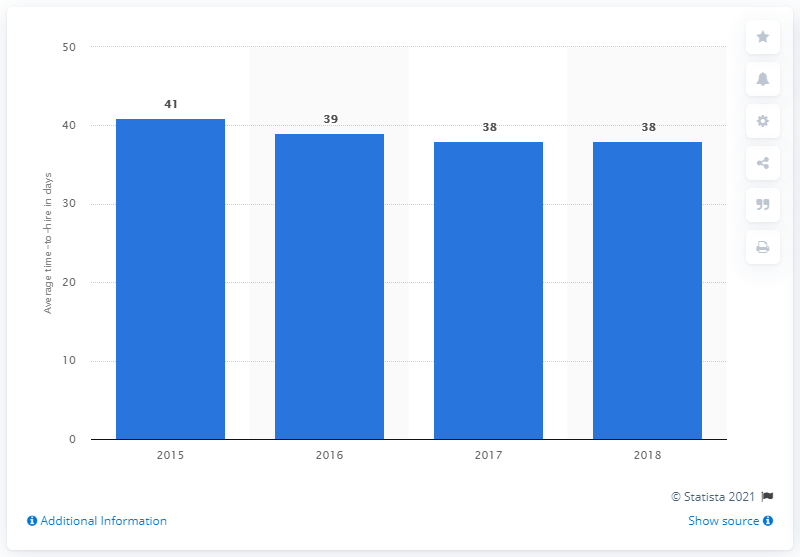Identify some key points in this picture. In 2015, the average time to hire for job applicants worldwide was typical. 